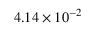Convert formula to latex. <formula><loc_0><loc_0><loc_500><loc_500>4 . 1 4 \times 1 0 ^ { - 2 }</formula> 